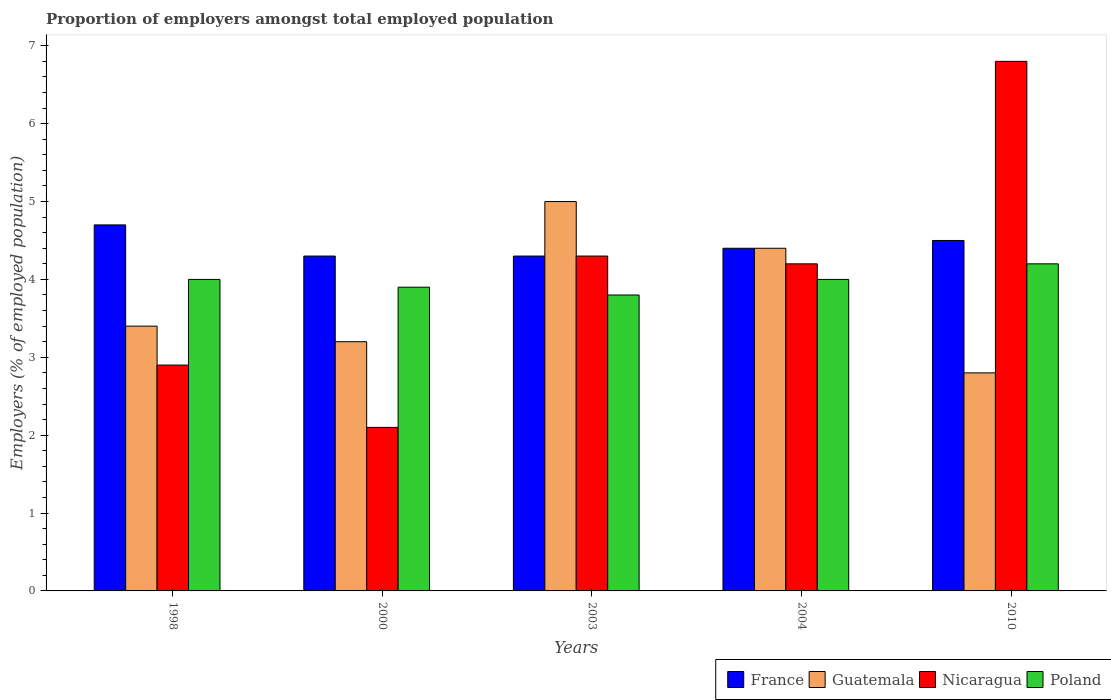How many groups of bars are there?
Make the answer very short. 5. Are the number of bars per tick equal to the number of legend labels?
Your answer should be very brief. Yes. How many bars are there on the 4th tick from the right?
Make the answer very short. 4. What is the proportion of employers in Nicaragua in 1998?
Make the answer very short. 2.9. Across all years, what is the maximum proportion of employers in Nicaragua?
Your answer should be compact. 6.8. Across all years, what is the minimum proportion of employers in Poland?
Give a very brief answer. 3.8. What is the total proportion of employers in Guatemala in the graph?
Your answer should be very brief. 18.8. What is the difference between the proportion of employers in France in 1998 and that in 2000?
Give a very brief answer. 0.4. What is the difference between the proportion of employers in Nicaragua in 2000 and the proportion of employers in Poland in 2004?
Provide a succinct answer. -1.9. What is the average proportion of employers in Guatemala per year?
Provide a short and direct response. 3.76. In the year 2003, what is the difference between the proportion of employers in Poland and proportion of employers in Nicaragua?
Provide a short and direct response. -0.5. In how many years, is the proportion of employers in Nicaragua greater than 1.2 %?
Ensure brevity in your answer.  5. What is the ratio of the proportion of employers in Poland in 2000 to that in 2010?
Give a very brief answer. 0.93. What is the difference between the highest and the second highest proportion of employers in Nicaragua?
Give a very brief answer. 2.5. What is the difference between the highest and the lowest proportion of employers in Guatemala?
Offer a terse response. 2.2. Is it the case that in every year, the sum of the proportion of employers in Guatemala and proportion of employers in France is greater than the sum of proportion of employers in Poland and proportion of employers in Nicaragua?
Offer a terse response. No. What does the 3rd bar from the left in 2010 represents?
Your response must be concise. Nicaragua. What does the 3rd bar from the right in 2000 represents?
Provide a succinct answer. Guatemala. How many bars are there?
Give a very brief answer. 20. Are all the bars in the graph horizontal?
Ensure brevity in your answer.  No. How many years are there in the graph?
Offer a very short reply. 5. Are the values on the major ticks of Y-axis written in scientific E-notation?
Ensure brevity in your answer.  No. Does the graph contain any zero values?
Keep it short and to the point. No. Where does the legend appear in the graph?
Ensure brevity in your answer.  Bottom right. How are the legend labels stacked?
Offer a terse response. Horizontal. What is the title of the graph?
Your answer should be compact. Proportion of employers amongst total employed population. What is the label or title of the X-axis?
Your answer should be very brief. Years. What is the label or title of the Y-axis?
Offer a very short reply. Employers (% of employed population). What is the Employers (% of employed population) of France in 1998?
Offer a very short reply. 4.7. What is the Employers (% of employed population) of Guatemala in 1998?
Offer a very short reply. 3.4. What is the Employers (% of employed population) in Nicaragua in 1998?
Your response must be concise. 2.9. What is the Employers (% of employed population) of France in 2000?
Your answer should be compact. 4.3. What is the Employers (% of employed population) in Guatemala in 2000?
Your answer should be compact. 3.2. What is the Employers (% of employed population) in Nicaragua in 2000?
Ensure brevity in your answer.  2.1. What is the Employers (% of employed population) in Poland in 2000?
Provide a short and direct response. 3.9. What is the Employers (% of employed population) of France in 2003?
Give a very brief answer. 4.3. What is the Employers (% of employed population) in Guatemala in 2003?
Ensure brevity in your answer.  5. What is the Employers (% of employed population) of Nicaragua in 2003?
Your answer should be compact. 4.3. What is the Employers (% of employed population) in Poland in 2003?
Offer a very short reply. 3.8. What is the Employers (% of employed population) of France in 2004?
Give a very brief answer. 4.4. What is the Employers (% of employed population) in Guatemala in 2004?
Offer a terse response. 4.4. What is the Employers (% of employed population) in Nicaragua in 2004?
Give a very brief answer. 4.2. What is the Employers (% of employed population) in Guatemala in 2010?
Provide a succinct answer. 2.8. What is the Employers (% of employed population) of Nicaragua in 2010?
Offer a terse response. 6.8. What is the Employers (% of employed population) in Poland in 2010?
Ensure brevity in your answer.  4.2. Across all years, what is the maximum Employers (% of employed population) in France?
Provide a short and direct response. 4.7. Across all years, what is the maximum Employers (% of employed population) in Nicaragua?
Offer a terse response. 6.8. Across all years, what is the maximum Employers (% of employed population) of Poland?
Ensure brevity in your answer.  4.2. Across all years, what is the minimum Employers (% of employed population) of France?
Your response must be concise. 4.3. Across all years, what is the minimum Employers (% of employed population) of Guatemala?
Ensure brevity in your answer.  2.8. Across all years, what is the minimum Employers (% of employed population) in Nicaragua?
Make the answer very short. 2.1. Across all years, what is the minimum Employers (% of employed population) of Poland?
Keep it short and to the point. 3.8. What is the total Employers (% of employed population) of France in the graph?
Provide a short and direct response. 22.2. What is the total Employers (% of employed population) of Guatemala in the graph?
Your answer should be compact. 18.8. What is the total Employers (% of employed population) in Nicaragua in the graph?
Your answer should be very brief. 20.3. What is the total Employers (% of employed population) in Poland in the graph?
Your answer should be compact. 19.9. What is the difference between the Employers (% of employed population) of Guatemala in 1998 and that in 2000?
Provide a short and direct response. 0.2. What is the difference between the Employers (% of employed population) in Poland in 1998 and that in 2000?
Offer a terse response. 0.1. What is the difference between the Employers (% of employed population) in Guatemala in 1998 and that in 2003?
Make the answer very short. -1.6. What is the difference between the Employers (% of employed population) in France in 1998 and that in 2004?
Your answer should be compact. 0.3. What is the difference between the Employers (% of employed population) in Nicaragua in 1998 and that in 2004?
Make the answer very short. -1.3. What is the difference between the Employers (% of employed population) in Poland in 1998 and that in 2004?
Offer a very short reply. 0. What is the difference between the Employers (% of employed population) in France in 1998 and that in 2010?
Keep it short and to the point. 0.2. What is the difference between the Employers (% of employed population) of Guatemala in 1998 and that in 2010?
Give a very brief answer. 0.6. What is the difference between the Employers (% of employed population) in Poland in 1998 and that in 2010?
Your response must be concise. -0.2. What is the difference between the Employers (% of employed population) of France in 2000 and that in 2003?
Keep it short and to the point. 0. What is the difference between the Employers (% of employed population) in France in 2000 and that in 2004?
Your response must be concise. -0.1. What is the difference between the Employers (% of employed population) of Nicaragua in 2000 and that in 2004?
Offer a terse response. -2.1. What is the difference between the Employers (% of employed population) of Guatemala in 2000 and that in 2010?
Make the answer very short. 0.4. What is the difference between the Employers (% of employed population) in Nicaragua in 2000 and that in 2010?
Offer a very short reply. -4.7. What is the difference between the Employers (% of employed population) of Guatemala in 2003 and that in 2004?
Your response must be concise. 0.6. What is the difference between the Employers (% of employed population) of Poland in 2003 and that in 2004?
Provide a short and direct response. -0.2. What is the difference between the Employers (% of employed population) of Guatemala in 2003 and that in 2010?
Keep it short and to the point. 2.2. What is the difference between the Employers (% of employed population) in Poland in 2003 and that in 2010?
Provide a succinct answer. -0.4. What is the difference between the Employers (% of employed population) of France in 2004 and that in 2010?
Make the answer very short. -0.1. What is the difference between the Employers (% of employed population) in Guatemala in 2004 and that in 2010?
Provide a succinct answer. 1.6. What is the difference between the Employers (% of employed population) of Nicaragua in 2004 and that in 2010?
Make the answer very short. -2.6. What is the difference between the Employers (% of employed population) of Poland in 2004 and that in 2010?
Your answer should be compact. -0.2. What is the difference between the Employers (% of employed population) in Guatemala in 1998 and the Employers (% of employed population) in Nicaragua in 2000?
Offer a very short reply. 1.3. What is the difference between the Employers (% of employed population) of France in 1998 and the Employers (% of employed population) of Poland in 2003?
Keep it short and to the point. 0.9. What is the difference between the Employers (% of employed population) of Guatemala in 1998 and the Employers (% of employed population) of Poland in 2003?
Ensure brevity in your answer.  -0.4. What is the difference between the Employers (% of employed population) in Nicaragua in 1998 and the Employers (% of employed population) in Poland in 2003?
Keep it short and to the point. -0.9. What is the difference between the Employers (% of employed population) of France in 1998 and the Employers (% of employed population) of Nicaragua in 2004?
Provide a succinct answer. 0.5. What is the difference between the Employers (% of employed population) of Guatemala in 1998 and the Employers (% of employed population) of Nicaragua in 2004?
Your answer should be very brief. -0.8. What is the difference between the Employers (% of employed population) of Nicaragua in 1998 and the Employers (% of employed population) of Poland in 2004?
Offer a terse response. -1.1. What is the difference between the Employers (% of employed population) of France in 1998 and the Employers (% of employed population) of Guatemala in 2010?
Offer a very short reply. 1.9. What is the difference between the Employers (% of employed population) of France in 1998 and the Employers (% of employed population) of Nicaragua in 2010?
Keep it short and to the point. -2.1. What is the difference between the Employers (% of employed population) in Nicaragua in 1998 and the Employers (% of employed population) in Poland in 2010?
Offer a terse response. -1.3. What is the difference between the Employers (% of employed population) of France in 2000 and the Employers (% of employed population) of Poland in 2003?
Make the answer very short. 0.5. What is the difference between the Employers (% of employed population) in Guatemala in 2000 and the Employers (% of employed population) in Nicaragua in 2003?
Your answer should be very brief. -1.1. What is the difference between the Employers (% of employed population) in Nicaragua in 2000 and the Employers (% of employed population) in Poland in 2003?
Ensure brevity in your answer.  -1.7. What is the difference between the Employers (% of employed population) in Guatemala in 2000 and the Employers (% of employed population) in Nicaragua in 2004?
Offer a very short reply. -1. What is the difference between the Employers (% of employed population) in Nicaragua in 2000 and the Employers (% of employed population) in Poland in 2004?
Your response must be concise. -1.9. What is the difference between the Employers (% of employed population) of France in 2000 and the Employers (% of employed population) of Guatemala in 2010?
Make the answer very short. 1.5. What is the difference between the Employers (% of employed population) in France in 2000 and the Employers (% of employed population) in Poland in 2010?
Provide a succinct answer. 0.1. What is the difference between the Employers (% of employed population) in Guatemala in 2000 and the Employers (% of employed population) in Nicaragua in 2010?
Your answer should be very brief. -3.6. What is the difference between the Employers (% of employed population) in Guatemala in 2000 and the Employers (% of employed population) in Poland in 2010?
Your answer should be very brief. -1. What is the difference between the Employers (% of employed population) of Nicaragua in 2000 and the Employers (% of employed population) of Poland in 2010?
Keep it short and to the point. -2.1. What is the difference between the Employers (% of employed population) of France in 2003 and the Employers (% of employed population) of Guatemala in 2004?
Make the answer very short. -0.1. What is the difference between the Employers (% of employed population) in France in 2003 and the Employers (% of employed population) in Poland in 2004?
Ensure brevity in your answer.  0.3. What is the difference between the Employers (% of employed population) of Nicaragua in 2003 and the Employers (% of employed population) of Poland in 2004?
Make the answer very short. 0.3. What is the difference between the Employers (% of employed population) of Guatemala in 2003 and the Employers (% of employed population) of Nicaragua in 2010?
Ensure brevity in your answer.  -1.8. What is the difference between the Employers (% of employed population) of Guatemala in 2004 and the Employers (% of employed population) of Nicaragua in 2010?
Provide a succinct answer. -2.4. What is the difference between the Employers (% of employed population) of Nicaragua in 2004 and the Employers (% of employed population) of Poland in 2010?
Ensure brevity in your answer.  0. What is the average Employers (% of employed population) in France per year?
Offer a very short reply. 4.44. What is the average Employers (% of employed population) of Guatemala per year?
Provide a succinct answer. 3.76. What is the average Employers (% of employed population) in Nicaragua per year?
Make the answer very short. 4.06. What is the average Employers (% of employed population) in Poland per year?
Keep it short and to the point. 3.98. In the year 1998, what is the difference between the Employers (% of employed population) of France and Employers (% of employed population) of Guatemala?
Your response must be concise. 1.3. In the year 1998, what is the difference between the Employers (% of employed population) of France and Employers (% of employed population) of Nicaragua?
Offer a very short reply. 1.8. In the year 1998, what is the difference between the Employers (% of employed population) in Guatemala and Employers (% of employed population) in Nicaragua?
Your response must be concise. 0.5. In the year 1998, what is the difference between the Employers (% of employed population) of Guatemala and Employers (% of employed population) of Poland?
Your response must be concise. -0.6. In the year 1998, what is the difference between the Employers (% of employed population) in Nicaragua and Employers (% of employed population) in Poland?
Your response must be concise. -1.1. In the year 2000, what is the difference between the Employers (% of employed population) of France and Employers (% of employed population) of Guatemala?
Provide a succinct answer. 1.1. In the year 2000, what is the difference between the Employers (% of employed population) of France and Employers (% of employed population) of Nicaragua?
Ensure brevity in your answer.  2.2. In the year 2000, what is the difference between the Employers (% of employed population) in France and Employers (% of employed population) in Poland?
Make the answer very short. 0.4. In the year 2000, what is the difference between the Employers (% of employed population) in Nicaragua and Employers (% of employed population) in Poland?
Give a very brief answer. -1.8. In the year 2003, what is the difference between the Employers (% of employed population) of France and Employers (% of employed population) of Guatemala?
Offer a terse response. -0.7. In the year 2003, what is the difference between the Employers (% of employed population) in France and Employers (% of employed population) in Poland?
Keep it short and to the point. 0.5. In the year 2003, what is the difference between the Employers (% of employed population) in Guatemala and Employers (% of employed population) in Poland?
Make the answer very short. 1.2. In the year 2003, what is the difference between the Employers (% of employed population) of Nicaragua and Employers (% of employed population) of Poland?
Offer a very short reply. 0.5. In the year 2004, what is the difference between the Employers (% of employed population) in Guatemala and Employers (% of employed population) in Nicaragua?
Your answer should be compact. 0.2. In the year 2004, what is the difference between the Employers (% of employed population) in Guatemala and Employers (% of employed population) in Poland?
Give a very brief answer. 0.4. In the year 2010, what is the difference between the Employers (% of employed population) of France and Employers (% of employed population) of Poland?
Your answer should be very brief. 0.3. In the year 2010, what is the difference between the Employers (% of employed population) in Nicaragua and Employers (% of employed population) in Poland?
Offer a very short reply. 2.6. What is the ratio of the Employers (% of employed population) in France in 1998 to that in 2000?
Keep it short and to the point. 1.09. What is the ratio of the Employers (% of employed population) in Nicaragua in 1998 to that in 2000?
Provide a succinct answer. 1.38. What is the ratio of the Employers (% of employed population) of Poland in 1998 to that in 2000?
Offer a terse response. 1.03. What is the ratio of the Employers (% of employed population) of France in 1998 to that in 2003?
Keep it short and to the point. 1.09. What is the ratio of the Employers (% of employed population) of Guatemala in 1998 to that in 2003?
Offer a terse response. 0.68. What is the ratio of the Employers (% of employed population) in Nicaragua in 1998 to that in 2003?
Provide a succinct answer. 0.67. What is the ratio of the Employers (% of employed population) in Poland in 1998 to that in 2003?
Offer a terse response. 1.05. What is the ratio of the Employers (% of employed population) in France in 1998 to that in 2004?
Make the answer very short. 1.07. What is the ratio of the Employers (% of employed population) in Guatemala in 1998 to that in 2004?
Your answer should be compact. 0.77. What is the ratio of the Employers (% of employed population) of Nicaragua in 1998 to that in 2004?
Offer a terse response. 0.69. What is the ratio of the Employers (% of employed population) of Poland in 1998 to that in 2004?
Make the answer very short. 1. What is the ratio of the Employers (% of employed population) of France in 1998 to that in 2010?
Your answer should be very brief. 1.04. What is the ratio of the Employers (% of employed population) of Guatemala in 1998 to that in 2010?
Ensure brevity in your answer.  1.21. What is the ratio of the Employers (% of employed population) in Nicaragua in 1998 to that in 2010?
Your response must be concise. 0.43. What is the ratio of the Employers (% of employed population) of Guatemala in 2000 to that in 2003?
Your answer should be very brief. 0.64. What is the ratio of the Employers (% of employed population) in Nicaragua in 2000 to that in 2003?
Your response must be concise. 0.49. What is the ratio of the Employers (% of employed population) in Poland in 2000 to that in 2003?
Make the answer very short. 1.03. What is the ratio of the Employers (% of employed population) in France in 2000 to that in 2004?
Give a very brief answer. 0.98. What is the ratio of the Employers (% of employed population) of Guatemala in 2000 to that in 2004?
Provide a succinct answer. 0.73. What is the ratio of the Employers (% of employed population) in France in 2000 to that in 2010?
Offer a terse response. 0.96. What is the ratio of the Employers (% of employed population) in Nicaragua in 2000 to that in 2010?
Give a very brief answer. 0.31. What is the ratio of the Employers (% of employed population) of Poland in 2000 to that in 2010?
Keep it short and to the point. 0.93. What is the ratio of the Employers (% of employed population) of France in 2003 to that in 2004?
Your answer should be compact. 0.98. What is the ratio of the Employers (% of employed population) of Guatemala in 2003 to that in 2004?
Give a very brief answer. 1.14. What is the ratio of the Employers (% of employed population) in Nicaragua in 2003 to that in 2004?
Keep it short and to the point. 1.02. What is the ratio of the Employers (% of employed population) of Poland in 2003 to that in 2004?
Make the answer very short. 0.95. What is the ratio of the Employers (% of employed population) of France in 2003 to that in 2010?
Your response must be concise. 0.96. What is the ratio of the Employers (% of employed population) of Guatemala in 2003 to that in 2010?
Make the answer very short. 1.79. What is the ratio of the Employers (% of employed population) in Nicaragua in 2003 to that in 2010?
Offer a terse response. 0.63. What is the ratio of the Employers (% of employed population) in Poland in 2003 to that in 2010?
Give a very brief answer. 0.9. What is the ratio of the Employers (% of employed population) of France in 2004 to that in 2010?
Keep it short and to the point. 0.98. What is the ratio of the Employers (% of employed population) in Guatemala in 2004 to that in 2010?
Offer a very short reply. 1.57. What is the ratio of the Employers (% of employed population) in Nicaragua in 2004 to that in 2010?
Your answer should be compact. 0.62. What is the difference between the highest and the second highest Employers (% of employed population) of Guatemala?
Your response must be concise. 0.6. What is the difference between the highest and the second highest Employers (% of employed population) of Nicaragua?
Your answer should be compact. 2.5. What is the difference between the highest and the second highest Employers (% of employed population) of Poland?
Provide a short and direct response. 0.2. What is the difference between the highest and the lowest Employers (% of employed population) in Guatemala?
Give a very brief answer. 2.2. What is the difference between the highest and the lowest Employers (% of employed population) in Nicaragua?
Ensure brevity in your answer.  4.7. What is the difference between the highest and the lowest Employers (% of employed population) of Poland?
Ensure brevity in your answer.  0.4. 